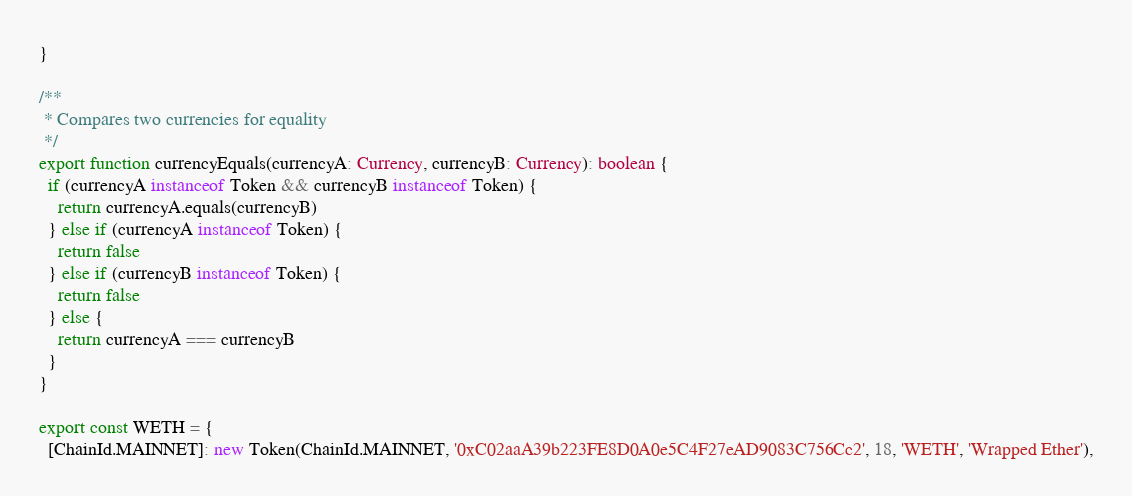<code> <loc_0><loc_0><loc_500><loc_500><_TypeScript_>}

/**
 * Compares two currencies for equality
 */
export function currencyEquals(currencyA: Currency, currencyB: Currency): boolean {
  if (currencyA instanceof Token && currencyB instanceof Token) {
    return currencyA.equals(currencyB)
  } else if (currencyA instanceof Token) {
    return false
  } else if (currencyB instanceof Token) {
    return false
  } else {
    return currencyA === currencyB
  }
}

export const WETH = {
  [ChainId.MAINNET]: new Token(ChainId.MAINNET, '0xC02aaA39b223FE8D0A0e5C4F27eAD9083C756Cc2', 18, 'WETH', 'Wrapped Ether'),</code> 